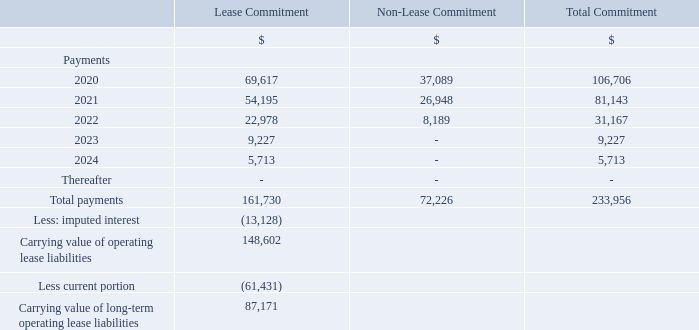10. Operating Leases
The Company charters-in vessels from other vessel owners on time-charter-in and bareboat charter contracts, whereby the vessel owner provides use of the vessel to the Company, and, in the case of time-charter-in contracts, also operates the vessel for the Company. A timecharter- in contract is typically for a fixed period of time, although in certain cases the Company may have the option to extend the charter.
The Company typically pays the owner a daily hire rate that is fixed over the duration of the charter. The Company is generally not required to pay the daily hire rate for time-charters during periods the vessel is not able to operate.
With respect to time-charter- With respect to time-charter-in and bareboat charter contracts with an original term of more than one year, for the year ended December 31, 2019, the Company incurred $99.0 million of time-charter and bareboat hire expense related to these time-charter and bareboat charter contracts, of which $68.2 million was allocable to the lease component, and $30.8 million was allocable to the non-lease component.
The amounts allocable to the lease component approximate the cash paid for the amounts included in lease liabilities and are reflected as a reduction in operating cash flows for the year ended December 31, 2019. Three of Teekay Tankers' time-charter-in contracts each have an option to extend the charter for an additional one-year term.
Since it is not reasonably certain that Teekay Tankers will exercise the options, the lease components of the options are not recognized as part of the right-of-use assets and lease liabilities. As at December 31, 2019, the weighted-average remaining lease term and weighted-average discount rate for these time-charter-in and bareboat charter contracts were 2.6 years and 6.1%, respectively.
During the year ended December 31, 2019, Teekay Tankers chartered in two LR2 vessels and one Aframax vessel for periods of 24 months each, Teekay LNG extended the charter-in contract for one LNG carrier for a period of 21 months, and Teekay Parent extended the charterin contract for one FSO unit for a period of 12 months, which resulted in the Company recognizing right-of-use assets and lease liabilities totaling $47.7 million and $47.7 million, respectively.
A maturity analysis of the Company’s operating lease liabilities from time-charter-in and bareboat charter contracts (excluding short-term leases) at December 31, 2019 is as follows:
As at December 31, 2019, minimum commitments to be incurred by the Company under short-term time-charter-in contracts were approximately $4.3 million (2020). As at December 31, 2018, minimum commitments to be incurred by the Company under vessel operating leases by which the Company charters-in vessels were approximately $116.3 million (2019), $90.4 million (2020), $53.4 million (2021), $9.1 million (2022), $9.1 million (2023) and $5.6 million thereafter.
What was the Lease and Non-Lease commitment in 2020?
Answer scale should be: thousand. 69,617, 37,089. What was the minimum commitments to be incurred by the Company under short-term time-charter-in contracts at December 2019? $99.0 million. What was the Lease commitment in 2021?
Answer scale should be: thousand. 54,195. In which year was the Lease commitment less than 10,000 thousands? Locate and analyze the lease commitments in column2 
answer: 2023, 2024. What is the increase / (decrease) in the Lease commitment from 2020 to 2021?
Answer scale should be: thousand. 54,195 - 69,617
Answer: -15422. What is the average Lease Commitment from 2020 to 2022?
Answer scale should be: thousand. (69,617 + 54,195 + 22,978) / 3
Answer: 48930. 